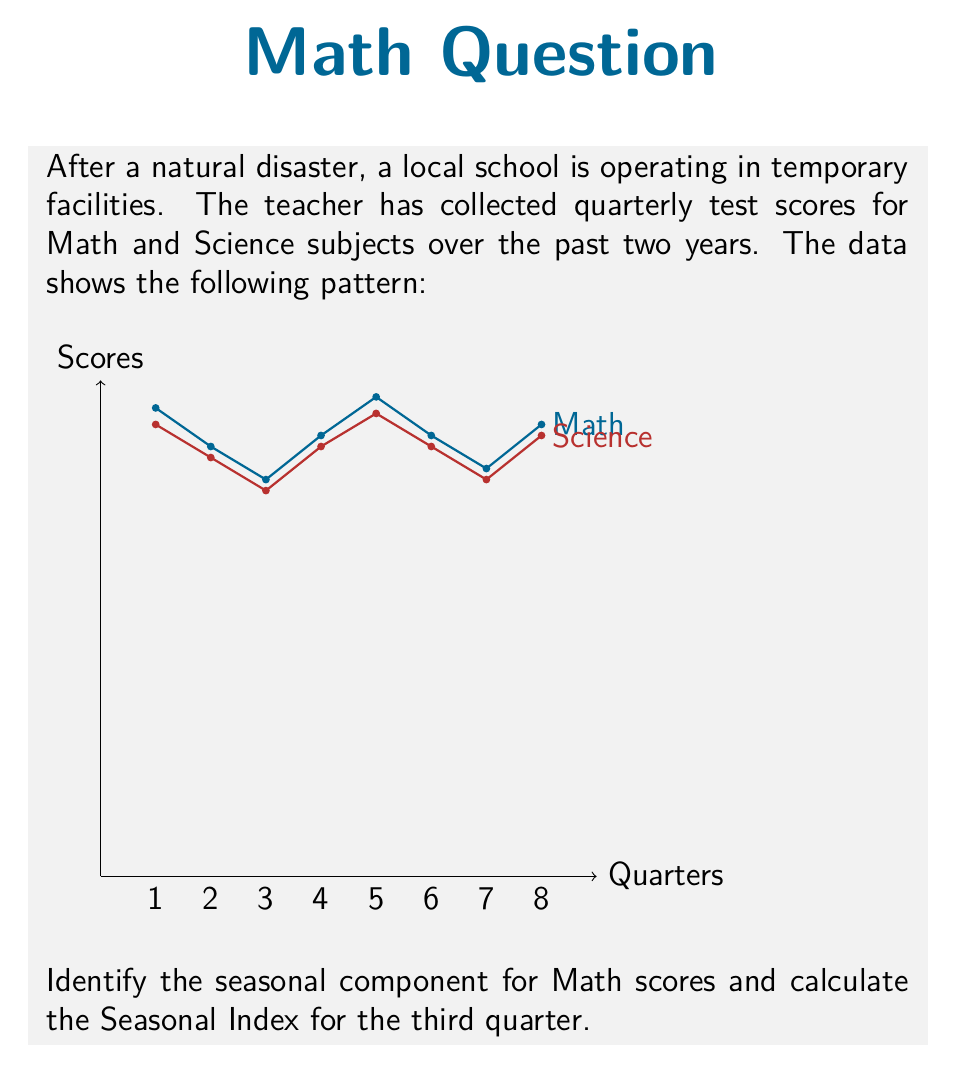Could you help me with this problem? To identify the seasonal component and calculate the Seasonal Index, we'll follow these steps:

1) First, we need to identify the cycle length. From the graph, we can see that the pattern repeats every 4 quarters, so our cycle length is 4.

2) Next, we'll calculate the average score for each quarter position across the two years:

   Q1: $(85 + 87) / 2 = 86$
   Q2: $(78 + 80) / 2 = 79$
   Q3: $(72 + 74) / 2 = 73$
   Q4: $(80 + 82) / 2 = 81$

3) Now, we calculate the overall average:

   Overall average = $(86 + 79 + 73 + 81) / 4 = 79.75$

4) The Seasonal Index for each quarter is calculated by dividing the quarter average by the overall average:

   Q1 Index: $86 / 79.75 = 1.078$
   Q2 Index: $79 / 79.75 = 0.991$
   Q3 Index: $73 / 79.75 = 0.915$
   Q4 Index: $81 / 79.75 = 1.016$

5) The question asks specifically for the Seasonal Index of the third quarter, which we calculated as 0.915.

6) To interpret this: a Seasonal Index less than 1 indicates that scores in this quarter tend to be below the overall average. Specifically, Q3 scores tend to be about 91.5% of the average score.
Answer: 0.915 